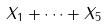<formula> <loc_0><loc_0><loc_500><loc_500>X _ { 1 } + \dots + X _ { 5 }</formula> 